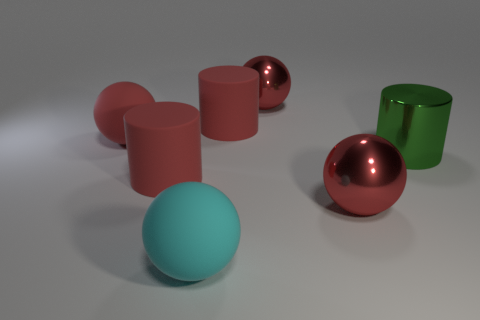Subtract all brown cylinders. How many red balls are left? 3 Add 1 big red matte spheres. How many objects exist? 8 Subtract all balls. How many objects are left? 3 Subtract all large green metal cylinders. Subtract all big red matte things. How many objects are left? 3 Add 4 large red metal spheres. How many large red metal spheres are left? 6 Add 5 large red things. How many large red things exist? 10 Subtract 0 gray cylinders. How many objects are left? 7 